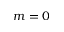<formula> <loc_0><loc_0><loc_500><loc_500>m = 0</formula> 